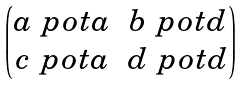<formula> <loc_0><loc_0><loc_500><loc_500>\begin{pmatrix} a \ p o t a & b \ p o t d \\ c \ p o t a & d \ p o t d \end{pmatrix}</formula> 